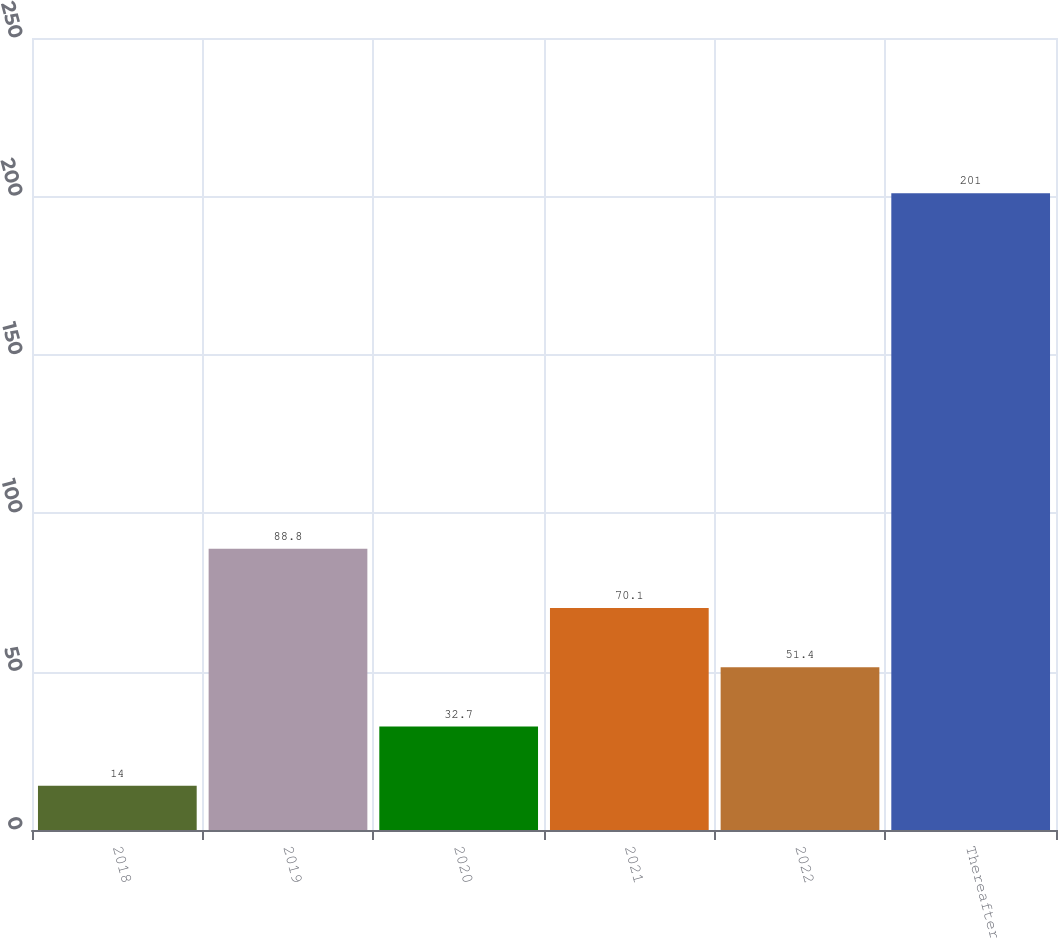Convert chart. <chart><loc_0><loc_0><loc_500><loc_500><bar_chart><fcel>2018<fcel>2019<fcel>2020<fcel>2021<fcel>2022<fcel>Thereafter<nl><fcel>14<fcel>88.8<fcel>32.7<fcel>70.1<fcel>51.4<fcel>201<nl></chart> 